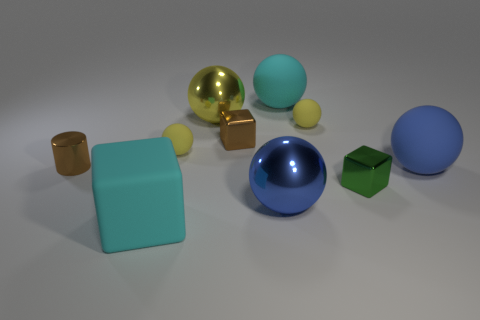How many things are small brown metallic balls or tiny metallic things right of the big cyan block?
Offer a terse response. 2. Are the large cyan thing in front of the small brown shiny cube and the large blue thing that is in front of the tiny green cube made of the same material?
Make the answer very short. No. What shape is the metal thing that is the same color as the small shiny cylinder?
Provide a short and direct response. Cube. What number of yellow things are big matte balls or metallic balls?
Your answer should be very brief. 1. What size is the brown shiny cube?
Offer a very short reply. Small. Is the number of metal cubes that are in front of the blue matte sphere greater than the number of small red rubber things?
Offer a terse response. Yes. There is a big yellow metal object; what number of large yellow metallic balls are behind it?
Ensure brevity in your answer.  0. Are there any cyan metallic balls of the same size as the blue matte object?
Ensure brevity in your answer.  No. What is the color of the other large metallic thing that is the same shape as the large yellow thing?
Your answer should be very brief. Blue. Do the shiny cube right of the tiny brown block and the cyan object that is left of the blue metallic ball have the same size?
Your answer should be very brief. No. 